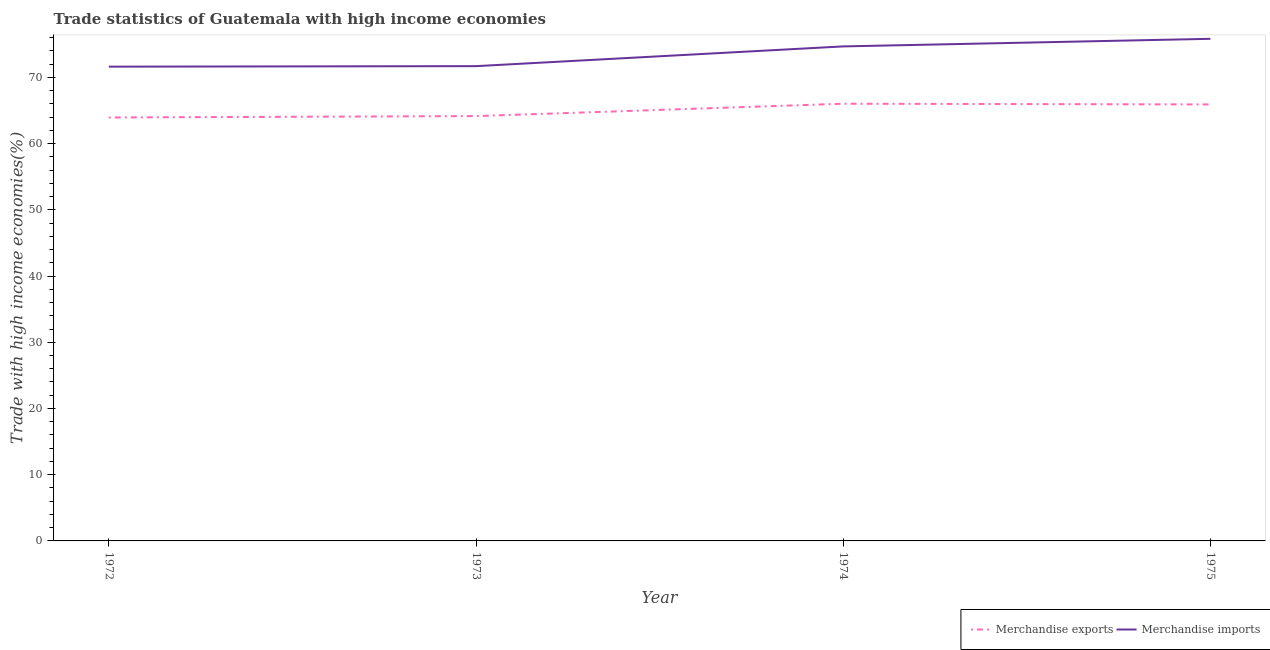How many different coloured lines are there?
Offer a very short reply. 2. Does the line corresponding to merchandise imports intersect with the line corresponding to merchandise exports?
Give a very brief answer. No. What is the merchandise imports in 1972?
Provide a short and direct response. 71.62. Across all years, what is the maximum merchandise imports?
Offer a very short reply. 75.82. Across all years, what is the minimum merchandise imports?
Offer a terse response. 71.62. In which year was the merchandise imports maximum?
Provide a succinct answer. 1975. In which year was the merchandise exports minimum?
Your answer should be compact. 1972. What is the total merchandise imports in the graph?
Provide a succinct answer. 293.8. What is the difference between the merchandise exports in 1972 and that in 1975?
Provide a short and direct response. -1.97. What is the difference between the merchandise exports in 1972 and the merchandise imports in 1973?
Provide a short and direct response. -7.75. What is the average merchandise imports per year?
Ensure brevity in your answer.  73.45. In the year 1974, what is the difference between the merchandise exports and merchandise imports?
Your response must be concise. -8.65. In how many years, is the merchandise imports greater than 50 %?
Make the answer very short. 4. What is the ratio of the merchandise exports in 1973 to that in 1974?
Give a very brief answer. 0.97. What is the difference between the highest and the second highest merchandise imports?
Keep it short and to the point. 1.15. What is the difference between the highest and the lowest merchandise imports?
Offer a terse response. 4.2. Is the merchandise imports strictly greater than the merchandise exports over the years?
Your answer should be compact. Yes. How many lines are there?
Your response must be concise. 2. Are the values on the major ticks of Y-axis written in scientific E-notation?
Offer a terse response. No. Does the graph contain any zero values?
Make the answer very short. No. Does the graph contain grids?
Your response must be concise. No. Where does the legend appear in the graph?
Provide a short and direct response. Bottom right. How are the legend labels stacked?
Provide a succinct answer. Horizontal. What is the title of the graph?
Ensure brevity in your answer.  Trade statistics of Guatemala with high income economies. What is the label or title of the Y-axis?
Your answer should be compact. Trade with high income economies(%). What is the Trade with high income economies(%) of Merchandise exports in 1972?
Offer a very short reply. 63.94. What is the Trade with high income economies(%) of Merchandise imports in 1972?
Keep it short and to the point. 71.62. What is the Trade with high income economies(%) of Merchandise exports in 1973?
Your response must be concise. 64.15. What is the Trade with high income economies(%) in Merchandise imports in 1973?
Your answer should be very brief. 71.69. What is the Trade with high income economies(%) in Merchandise exports in 1974?
Your answer should be very brief. 66.02. What is the Trade with high income economies(%) in Merchandise imports in 1974?
Your response must be concise. 74.67. What is the Trade with high income economies(%) in Merchandise exports in 1975?
Provide a short and direct response. 65.91. What is the Trade with high income economies(%) of Merchandise imports in 1975?
Your response must be concise. 75.82. Across all years, what is the maximum Trade with high income economies(%) of Merchandise exports?
Your answer should be compact. 66.02. Across all years, what is the maximum Trade with high income economies(%) in Merchandise imports?
Keep it short and to the point. 75.82. Across all years, what is the minimum Trade with high income economies(%) of Merchandise exports?
Keep it short and to the point. 63.94. Across all years, what is the minimum Trade with high income economies(%) of Merchandise imports?
Offer a terse response. 71.62. What is the total Trade with high income economies(%) in Merchandise exports in the graph?
Make the answer very short. 260.02. What is the total Trade with high income economies(%) in Merchandise imports in the graph?
Keep it short and to the point. 293.8. What is the difference between the Trade with high income economies(%) in Merchandise exports in 1972 and that in 1973?
Your answer should be compact. -0.21. What is the difference between the Trade with high income economies(%) of Merchandise imports in 1972 and that in 1973?
Offer a terse response. -0.08. What is the difference between the Trade with high income economies(%) in Merchandise exports in 1972 and that in 1974?
Keep it short and to the point. -2.08. What is the difference between the Trade with high income economies(%) of Merchandise imports in 1972 and that in 1974?
Keep it short and to the point. -3.06. What is the difference between the Trade with high income economies(%) of Merchandise exports in 1972 and that in 1975?
Your answer should be compact. -1.97. What is the difference between the Trade with high income economies(%) in Merchandise imports in 1972 and that in 1975?
Provide a succinct answer. -4.2. What is the difference between the Trade with high income economies(%) in Merchandise exports in 1973 and that in 1974?
Your answer should be very brief. -1.87. What is the difference between the Trade with high income economies(%) of Merchandise imports in 1973 and that in 1974?
Offer a terse response. -2.98. What is the difference between the Trade with high income economies(%) of Merchandise exports in 1973 and that in 1975?
Your answer should be very brief. -1.76. What is the difference between the Trade with high income economies(%) in Merchandise imports in 1973 and that in 1975?
Offer a terse response. -4.13. What is the difference between the Trade with high income economies(%) of Merchandise exports in 1974 and that in 1975?
Offer a very short reply. 0.11. What is the difference between the Trade with high income economies(%) of Merchandise imports in 1974 and that in 1975?
Your response must be concise. -1.15. What is the difference between the Trade with high income economies(%) in Merchandise exports in 1972 and the Trade with high income economies(%) in Merchandise imports in 1973?
Provide a succinct answer. -7.75. What is the difference between the Trade with high income economies(%) of Merchandise exports in 1972 and the Trade with high income economies(%) of Merchandise imports in 1974?
Keep it short and to the point. -10.73. What is the difference between the Trade with high income economies(%) in Merchandise exports in 1972 and the Trade with high income economies(%) in Merchandise imports in 1975?
Make the answer very short. -11.88. What is the difference between the Trade with high income economies(%) in Merchandise exports in 1973 and the Trade with high income economies(%) in Merchandise imports in 1974?
Your response must be concise. -10.52. What is the difference between the Trade with high income economies(%) of Merchandise exports in 1973 and the Trade with high income economies(%) of Merchandise imports in 1975?
Give a very brief answer. -11.67. What is the difference between the Trade with high income economies(%) in Merchandise exports in 1974 and the Trade with high income economies(%) in Merchandise imports in 1975?
Offer a very short reply. -9.8. What is the average Trade with high income economies(%) in Merchandise exports per year?
Offer a very short reply. 65. What is the average Trade with high income economies(%) in Merchandise imports per year?
Offer a very short reply. 73.45. In the year 1972, what is the difference between the Trade with high income economies(%) of Merchandise exports and Trade with high income economies(%) of Merchandise imports?
Offer a very short reply. -7.67. In the year 1973, what is the difference between the Trade with high income economies(%) in Merchandise exports and Trade with high income economies(%) in Merchandise imports?
Ensure brevity in your answer.  -7.54. In the year 1974, what is the difference between the Trade with high income economies(%) of Merchandise exports and Trade with high income economies(%) of Merchandise imports?
Provide a short and direct response. -8.65. In the year 1975, what is the difference between the Trade with high income economies(%) in Merchandise exports and Trade with high income economies(%) in Merchandise imports?
Offer a very short reply. -9.91. What is the ratio of the Trade with high income economies(%) of Merchandise exports in 1972 to that in 1974?
Ensure brevity in your answer.  0.97. What is the ratio of the Trade with high income economies(%) in Merchandise imports in 1972 to that in 1974?
Your answer should be very brief. 0.96. What is the ratio of the Trade with high income economies(%) in Merchandise exports in 1972 to that in 1975?
Your response must be concise. 0.97. What is the ratio of the Trade with high income economies(%) in Merchandise imports in 1972 to that in 1975?
Make the answer very short. 0.94. What is the ratio of the Trade with high income economies(%) in Merchandise exports in 1973 to that in 1974?
Give a very brief answer. 0.97. What is the ratio of the Trade with high income economies(%) in Merchandise imports in 1973 to that in 1974?
Offer a terse response. 0.96. What is the ratio of the Trade with high income economies(%) of Merchandise exports in 1973 to that in 1975?
Offer a very short reply. 0.97. What is the ratio of the Trade with high income economies(%) in Merchandise imports in 1973 to that in 1975?
Your answer should be compact. 0.95. What is the ratio of the Trade with high income economies(%) of Merchandise exports in 1974 to that in 1975?
Your answer should be compact. 1. What is the ratio of the Trade with high income economies(%) of Merchandise imports in 1974 to that in 1975?
Provide a short and direct response. 0.98. What is the difference between the highest and the second highest Trade with high income economies(%) in Merchandise exports?
Make the answer very short. 0.11. What is the difference between the highest and the second highest Trade with high income economies(%) of Merchandise imports?
Provide a short and direct response. 1.15. What is the difference between the highest and the lowest Trade with high income economies(%) in Merchandise exports?
Ensure brevity in your answer.  2.08. What is the difference between the highest and the lowest Trade with high income economies(%) of Merchandise imports?
Provide a succinct answer. 4.2. 